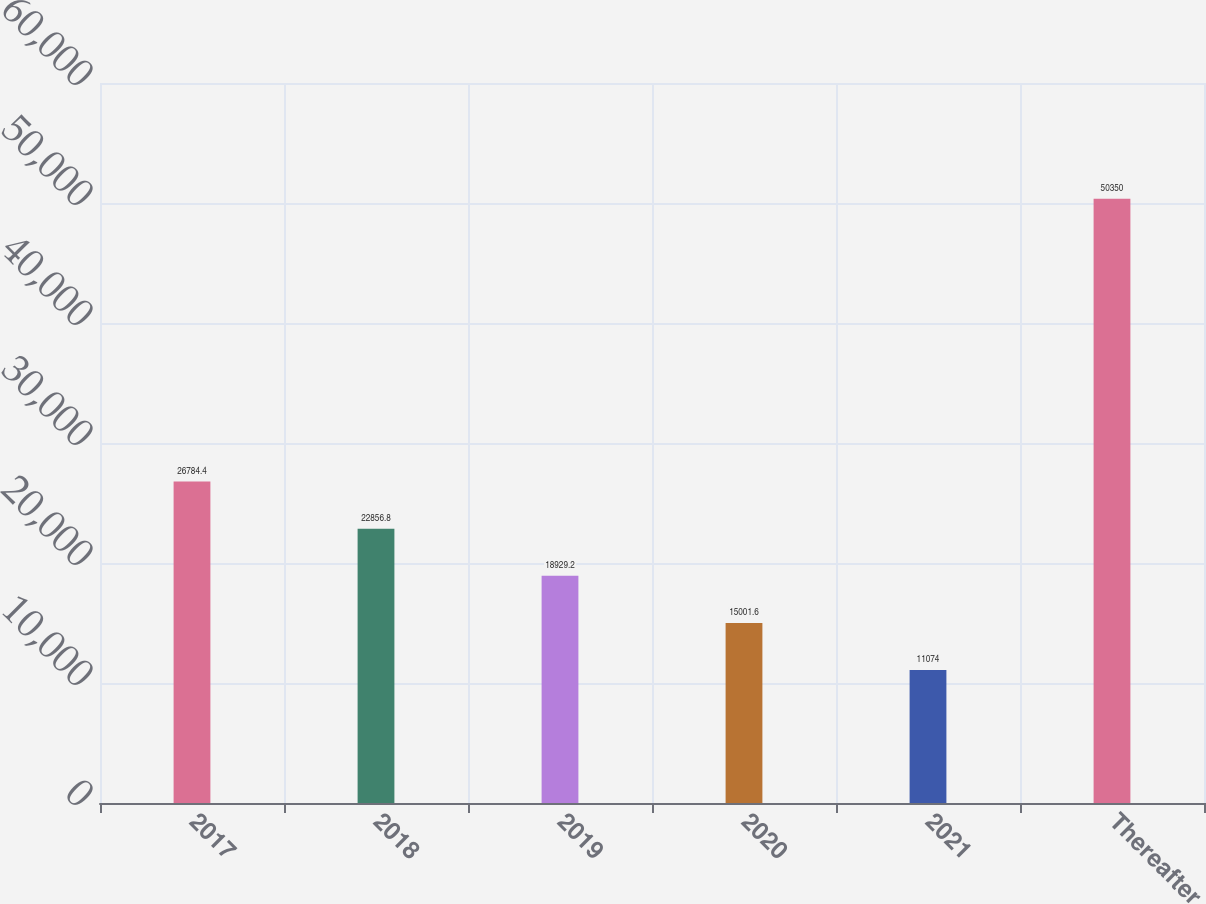<chart> <loc_0><loc_0><loc_500><loc_500><bar_chart><fcel>2017<fcel>2018<fcel>2019<fcel>2020<fcel>2021<fcel>Thereafter<nl><fcel>26784.4<fcel>22856.8<fcel>18929.2<fcel>15001.6<fcel>11074<fcel>50350<nl></chart> 